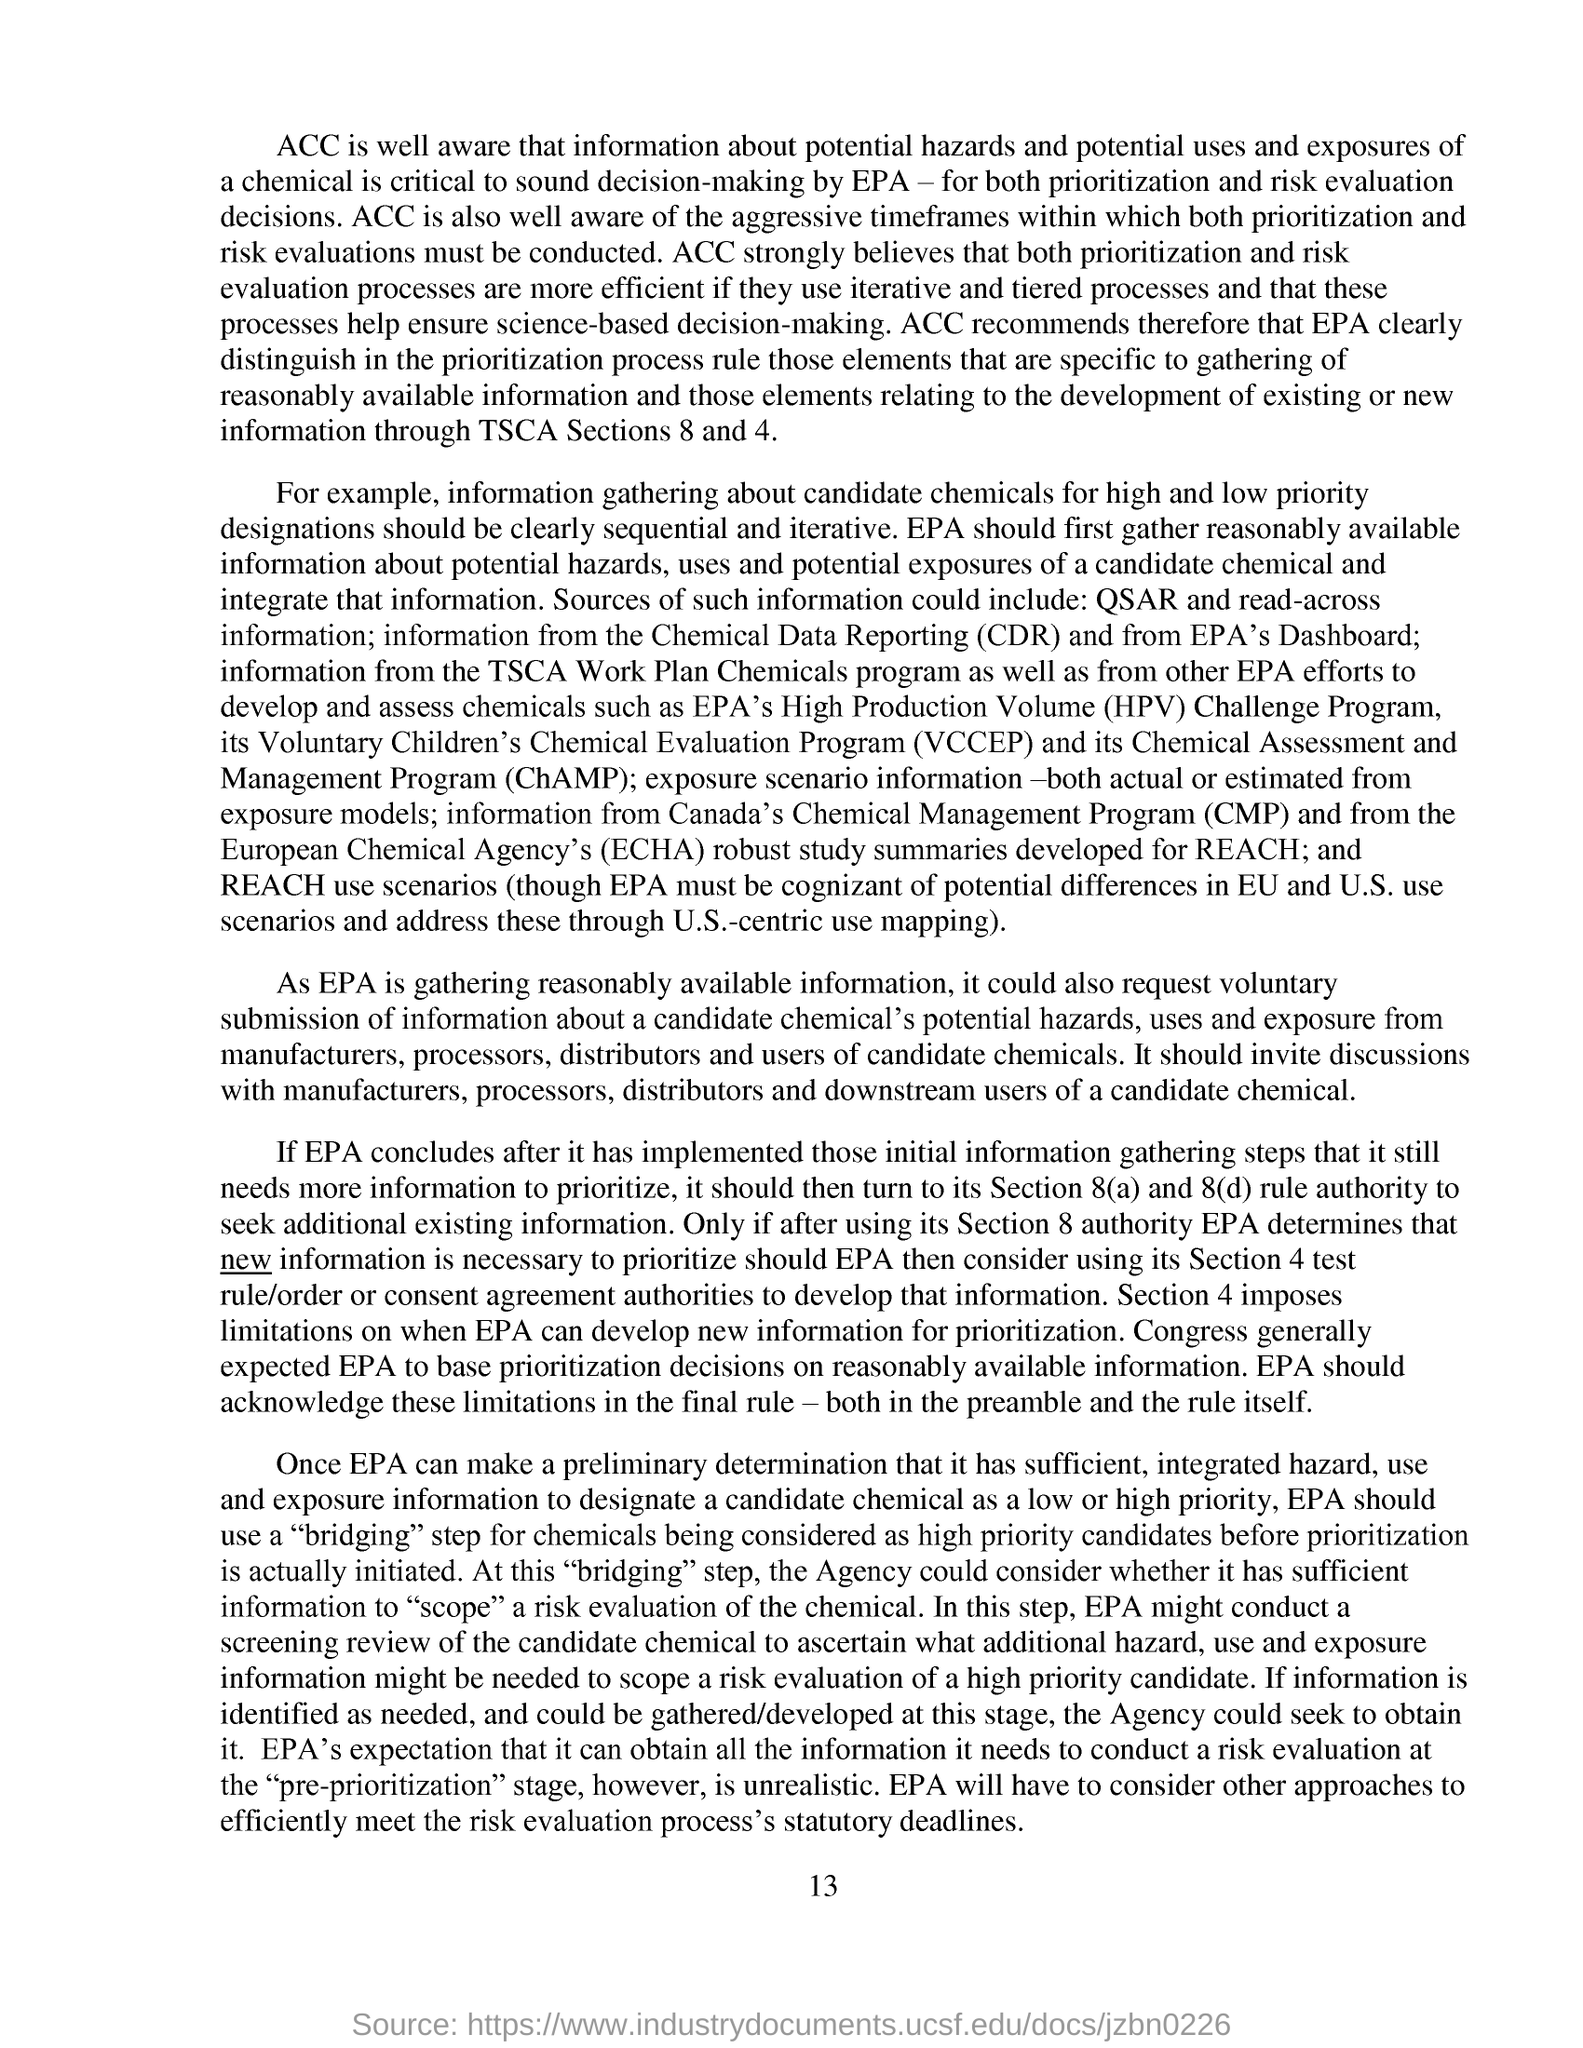Highlight a few significant elements in this photo. Chemical Assessment and Management Program" is an acronym that stands for "ChAMP". The page number mentioned in this document is 13. The abbreviation for Chemical Data Reporting is CDR. 